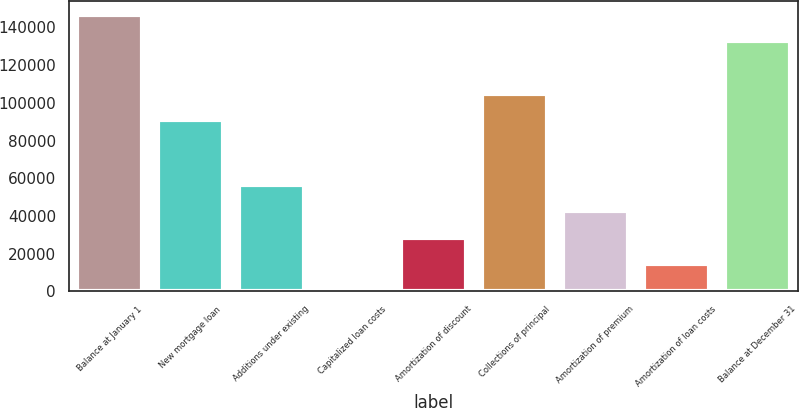<chart> <loc_0><loc_0><loc_500><loc_500><bar_chart><fcel>Balance at January 1<fcel>New mortgage loan<fcel>Additions under existing<fcel>Capitalized loan costs<fcel>Amortization of discount<fcel>Collections of principal<fcel>Amortization of premium<fcel>Amortization of loan costs<fcel>Balance at December 31<nl><fcel>146709<fcel>90886<fcel>56513<fcel>377<fcel>28445<fcel>104920<fcel>42479<fcel>14411<fcel>132675<nl></chart> 